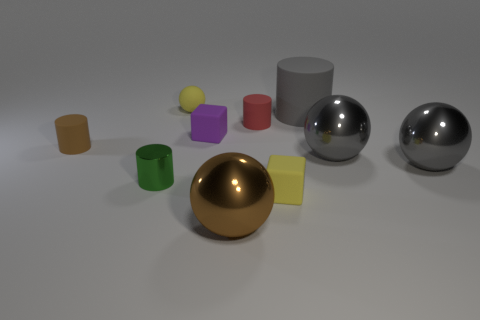Subtract 1 cylinders. How many cylinders are left? 3 Subtract all yellow cylinders. Subtract all cyan balls. How many cylinders are left? 4 Subtract all balls. How many objects are left? 6 Add 9 small purple things. How many small purple things are left? 10 Add 1 tiny blue metallic spheres. How many tiny blue metallic spheres exist? 1 Subtract 1 yellow balls. How many objects are left? 9 Subtract all small purple matte objects. Subtract all purple things. How many objects are left? 8 